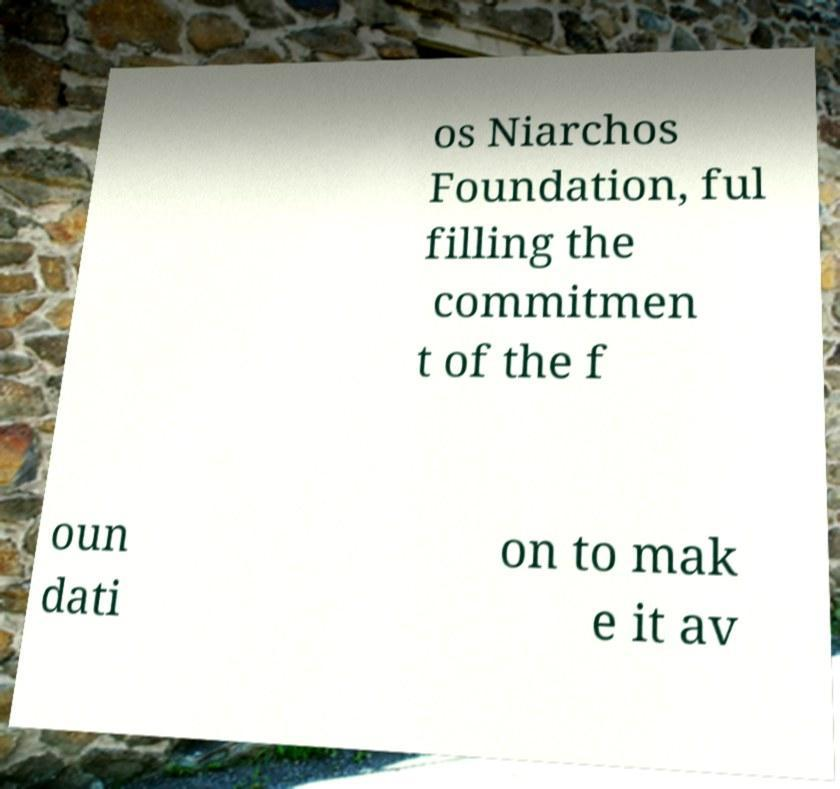I need the written content from this picture converted into text. Can you do that? os Niarchos Foundation, ful filling the commitmen t of the f oun dati on to mak e it av 